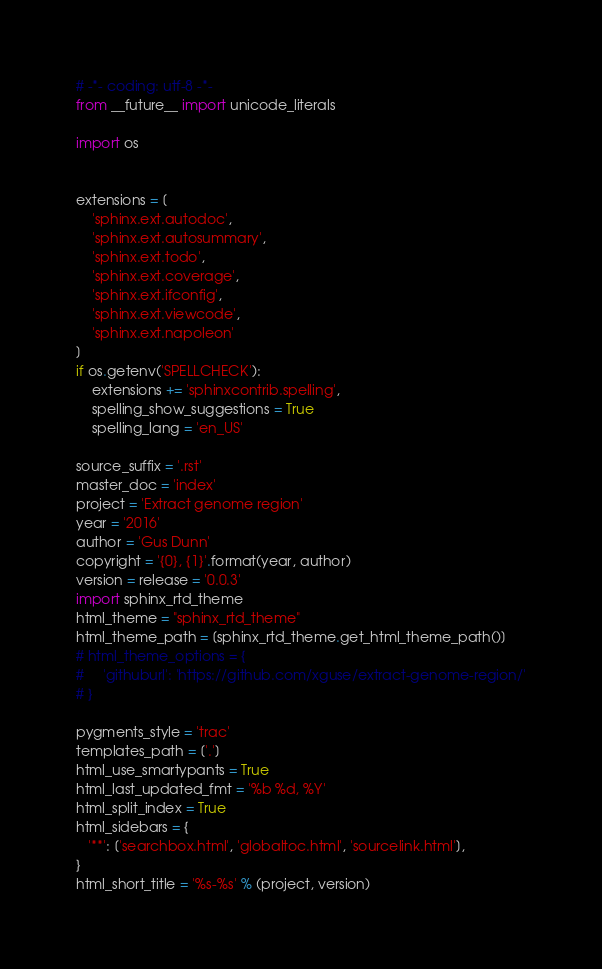<code> <loc_0><loc_0><loc_500><loc_500><_Python_># -*- coding: utf-8 -*-
from __future__ import unicode_literals

import os


extensions = [
    'sphinx.ext.autodoc',
    'sphinx.ext.autosummary',
    'sphinx.ext.todo',
    'sphinx.ext.coverage',
    'sphinx.ext.ifconfig',
    'sphinx.ext.viewcode',
    'sphinx.ext.napoleon'
]
if os.getenv('SPELLCHECK'):
    extensions += 'sphinxcontrib.spelling',
    spelling_show_suggestions = True
    spelling_lang = 'en_US'

source_suffix = '.rst'
master_doc = 'index'
project = 'Extract genome region'
year = '2016'
author = 'Gus Dunn'
copyright = '{0}, {1}'.format(year, author)
version = release = '0.0.3'
import sphinx_rtd_theme
html_theme = "sphinx_rtd_theme"
html_theme_path = [sphinx_rtd_theme.get_html_theme_path()]
# html_theme_options = {
#     'githuburl': 'https://github.com/xguse/extract-genome-region/'
# }

pygments_style = 'trac'
templates_path = ['.']
html_use_smartypants = True
html_last_updated_fmt = '%b %d, %Y'
html_split_index = True
html_sidebars = {
   '**': ['searchbox.html', 'globaltoc.html', 'sourcelink.html'],
}
html_short_title = '%s-%s' % (project, version)
</code> 